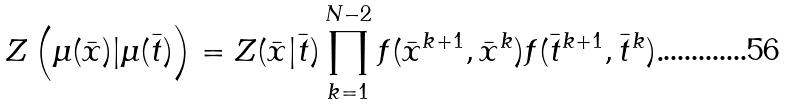<formula> <loc_0><loc_0><loc_500><loc_500>Z \left ( \mu ( \bar { x } ) | \mu ( \bar { t } ) \right ) = Z ( \bar { x } | \bar { t } ) \prod _ { k = 1 } ^ { N - 2 } f ( \bar { x } ^ { k + 1 } , \bar { x } ^ { k } ) f ( \bar { t } ^ { k + 1 } , \bar { t } ^ { k } ) .</formula> 